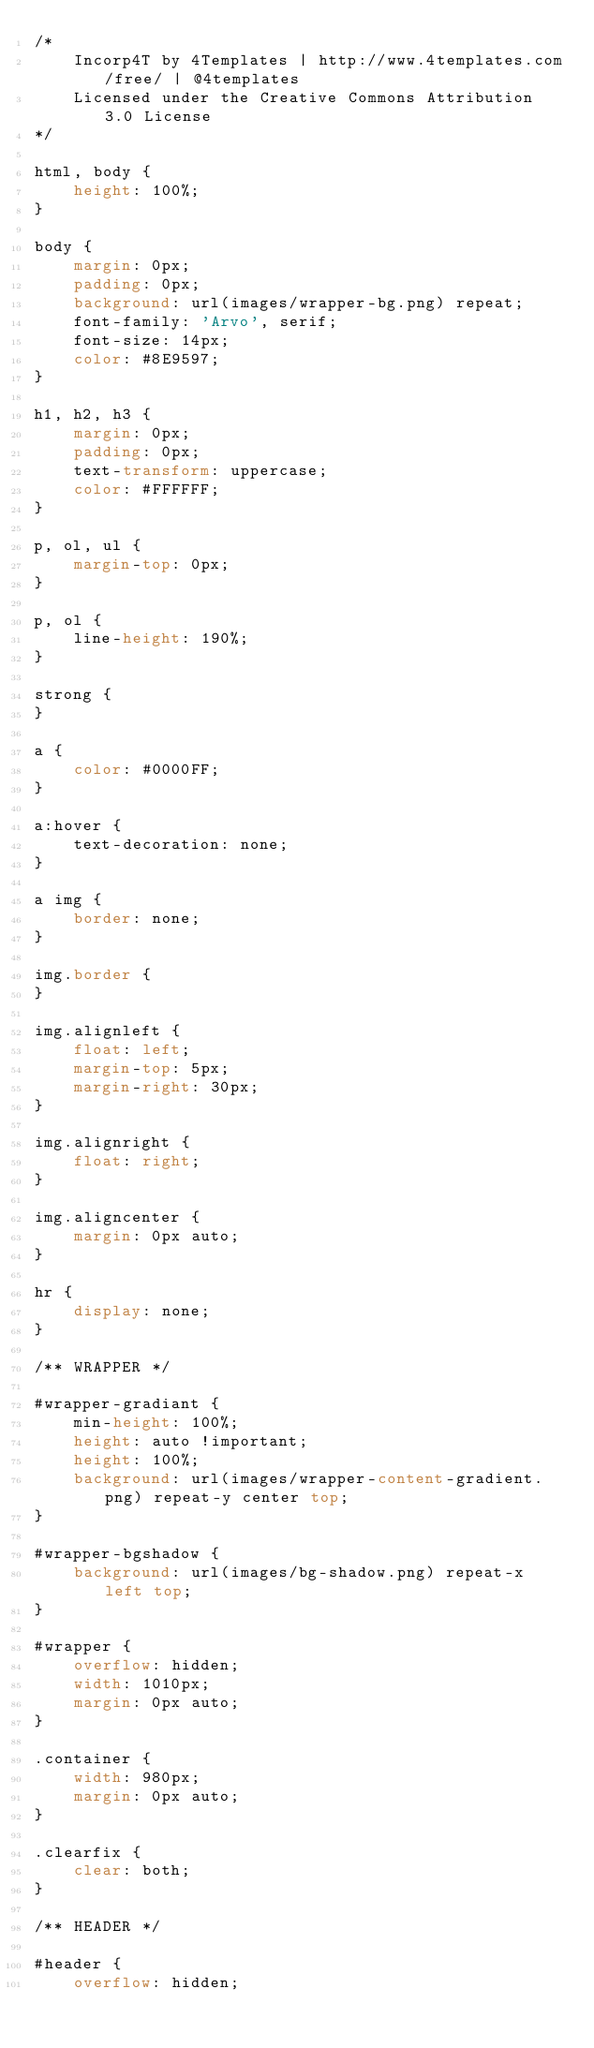Convert code to text. <code><loc_0><loc_0><loc_500><loc_500><_CSS_>/*
	Incorp4T by 4Templates | http://www.4templates.com/free/ | @4templates
	Licensed under the Creative Commons Attribution 3.0 License
*/

html, body {
	height: 100%;
}

body {
	margin: 0px;
	padding: 0px;
	background: url(images/wrapper-bg.png) repeat;
	font-family: 'Arvo', serif;
	font-size: 14px;
	color: #8E9597;
}

h1, h2, h3 {
	margin: 0px;
	padding: 0px;
	text-transform: uppercase;
	color: #FFFFFF;
}

p, ol, ul {
	margin-top: 0px;
}

p, ol {
	line-height: 190%;
}

strong {
}

a {
	color: #0000FF;
}

a:hover {
	text-decoration: none;
}

a img {
	border: none;
}

img.border {
}

img.alignleft {
	float: left;
	margin-top: 5px;
	margin-right: 30px;
}

img.alignright {
	float: right;
}

img.aligncenter {
	margin: 0px auto;
}

hr {
	display: none;
}

/** WRAPPER */

#wrapper-gradiant {
	min-height: 100%;
	height: auto !important;
	height: 100%;
	background: url(images/wrapper-content-gradient.png) repeat-y center top;
}

#wrapper-bgshadow {
	background: url(images/bg-shadow.png) repeat-x left top;
}

#wrapper {
	overflow: hidden;
	width: 1010px;
	margin: 0px auto;
}

.container {
	width: 980px;
	margin: 0px auto;
}

.clearfix {
	clear: both;
}

/** HEADER */

#header {
	overflow: hidden;</code> 